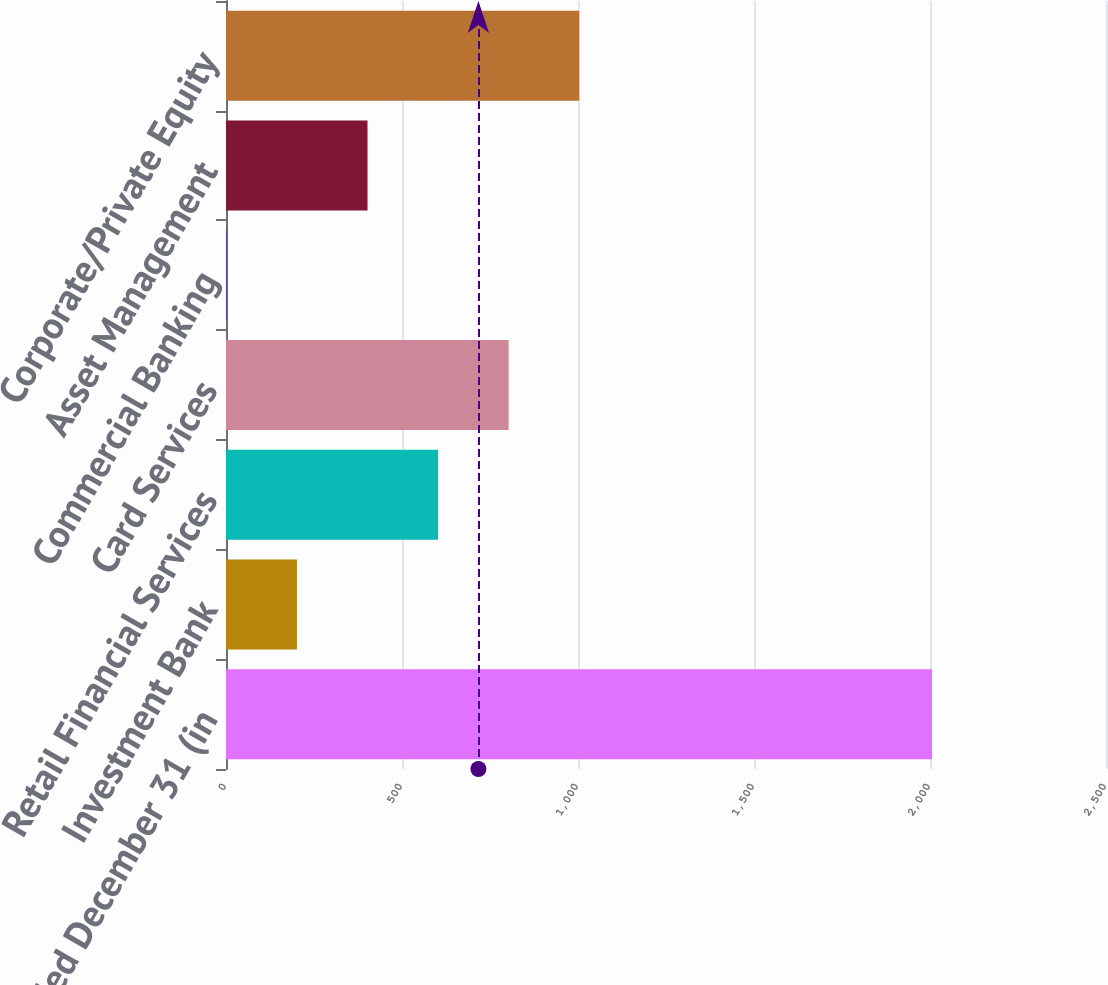Convert chart to OTSL. <chart><loc_0><loc_0><loc_500><loc_500><bar_chart><fcel>Year ended December 31 (in<fcel>Investment Bank<fcel>Retail Financial Services<fcel>Card Services<fcel>Commercial Banking<fcel>Asset Management<fcel>Corporate/Private Equity<nl><fcel>2006<fcel>201.5<fcel>602.5<fcel>803<fcel>1<fcel>402<fcel>1003.5<nl></chart> 